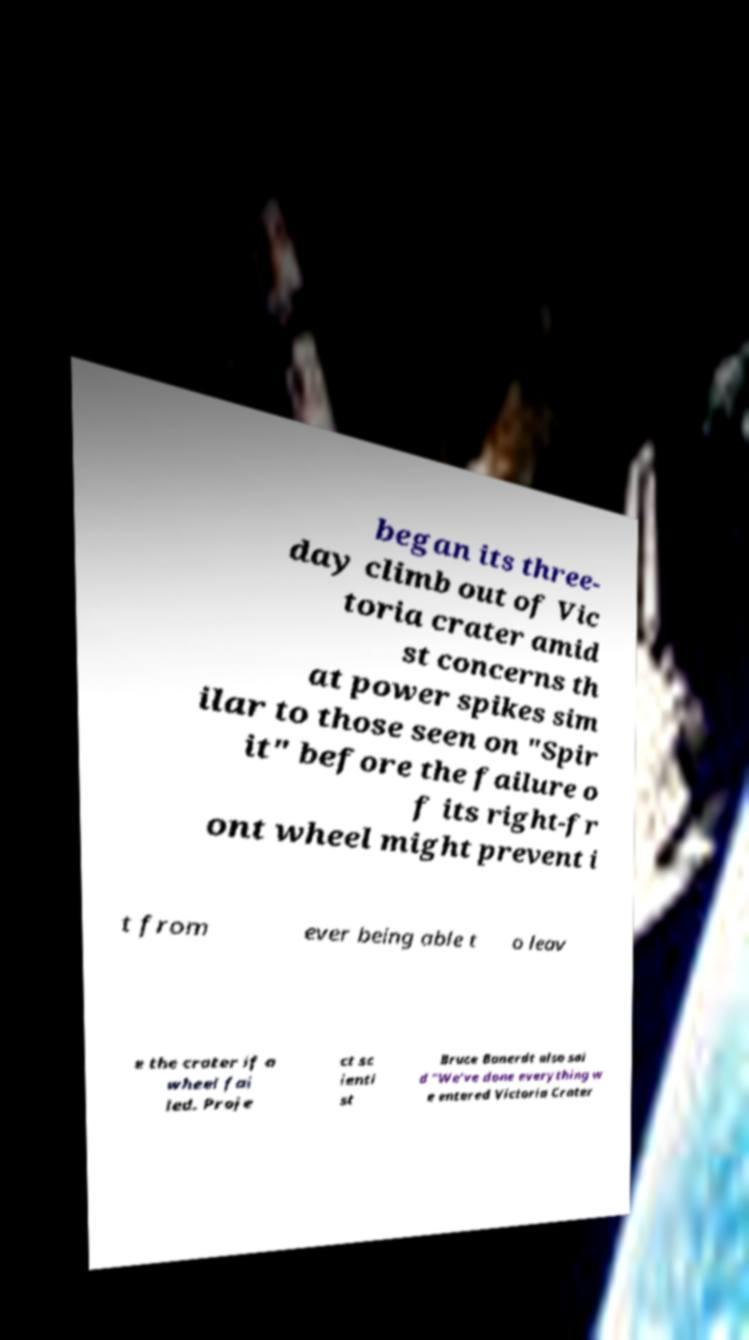Can you accurately transcribe the text from the provided image for me? began its three- day climb out of Vic toria crater amid st concerns th at power spikes sim ilar to those seen on "Spir it" before the failure o f its right-fr ont wheel might prevent i t from ever being able t o leav e the crater if a wheel fai led. Proje ct sc ienti st Bruce Banerdt also sai d "We've done everything w e entered Victoria Crater 